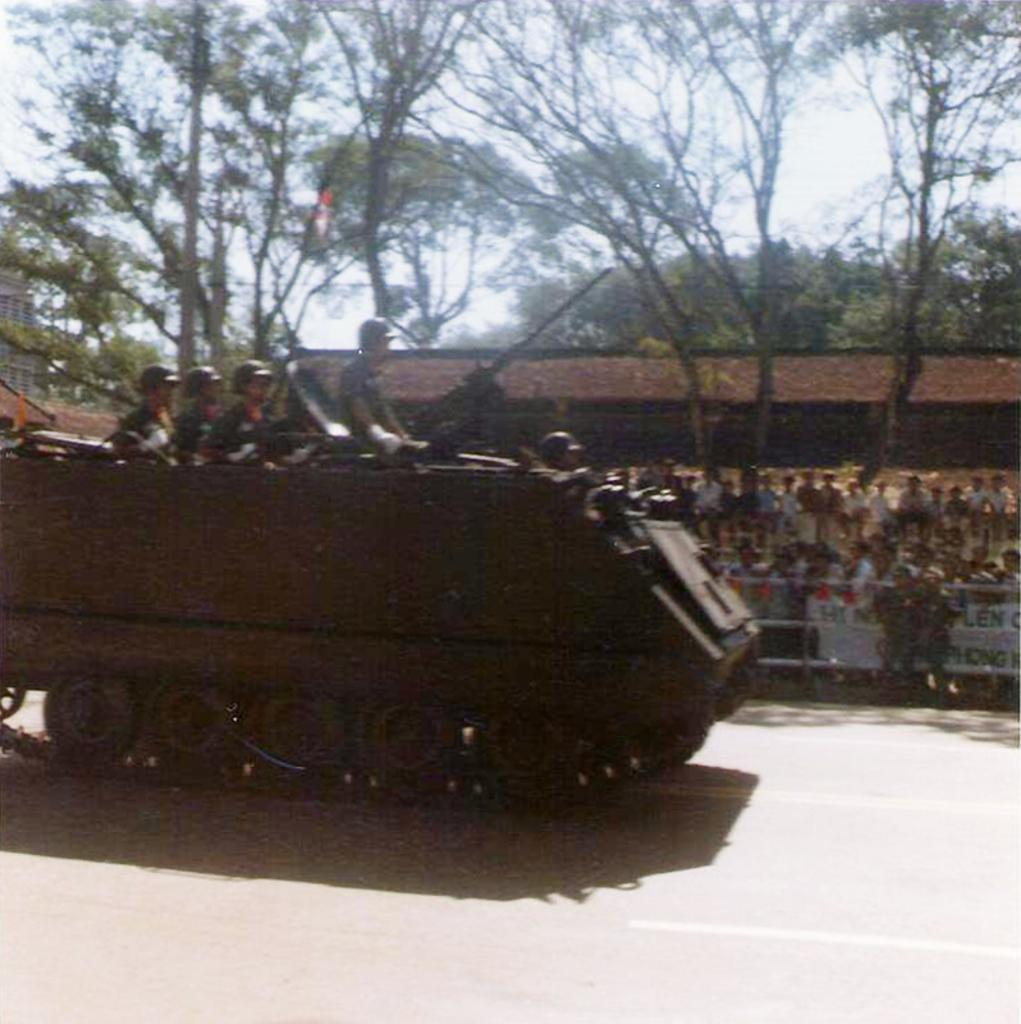What is the main subject of the image? The main subject of the image is a war tank on the road. What can be seen in the background of the image? There are trees, people, and houses in the background of the image. How loud is the quiet street in the image? The image does not mention the street being quiet, and the presence of a war tank suggests that it may not be a quiet environment. 